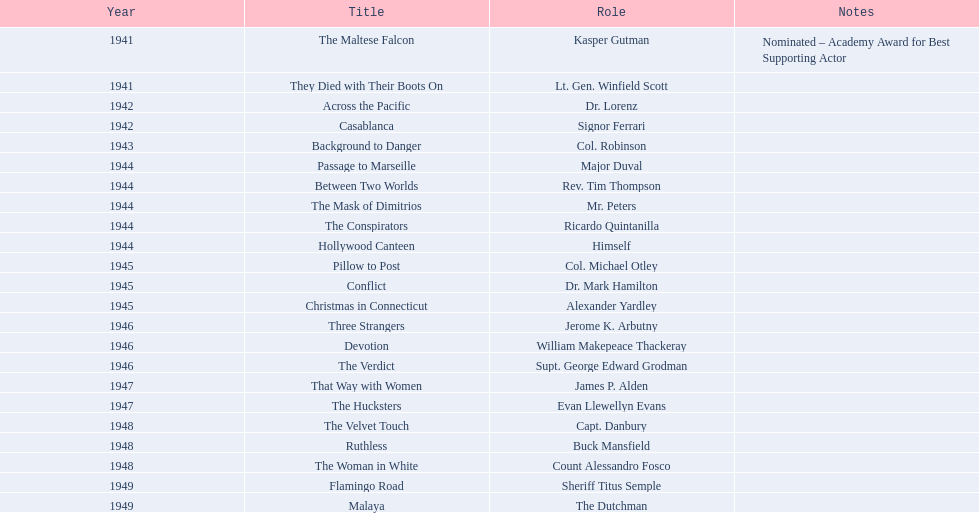In which year was the film that received a nomination? 1941. What was the name of the film? The Maltese Falcon. 